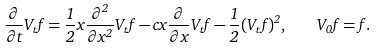Convert formula to latex. <formula><loc_0><loc_0><loc_500><loc_500>\frac { \partial } { \partial t } V _ { t } f = \frac { 1 } { 2 } x \frac { \partial ^ { 2 } } { \partial x ^ { 2 } } V _ { t } f - c x \frac { \partial } { \partial x } V _ { t } f - \frac { 1 } { 2 } ( V _ { t } f ) ^ { 2 } , \quad V _ { 0 } f = f .</formula> 